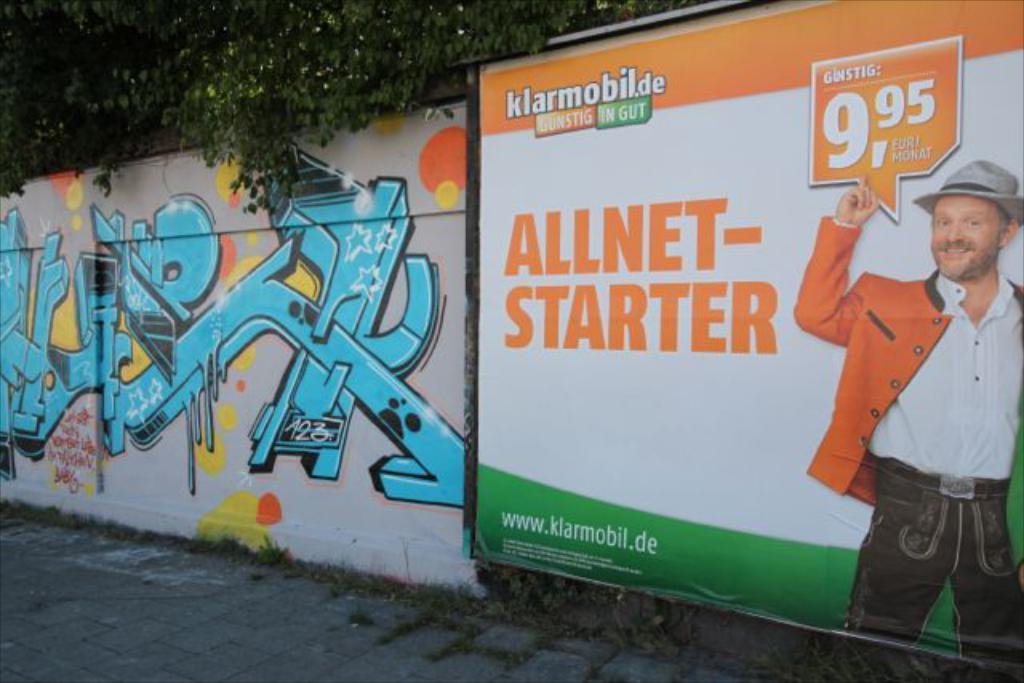<image>
Describe the image concisely. An ad for Klarmobile has a guy in a hat. 